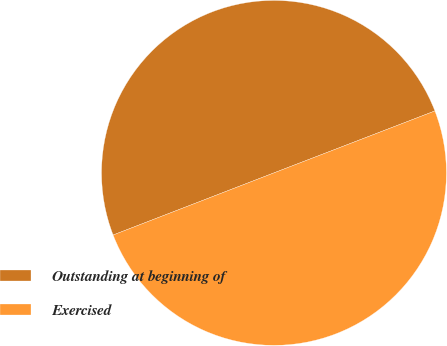Convert chart to OTSL. <chart><loc_0><loc_0><loc_500><loc_500><pie_chart><fcel>Outstanding at beginning of<fcel>Exercised<nl><fcel>50.02%<fcel>49.98%<nl></chart> 